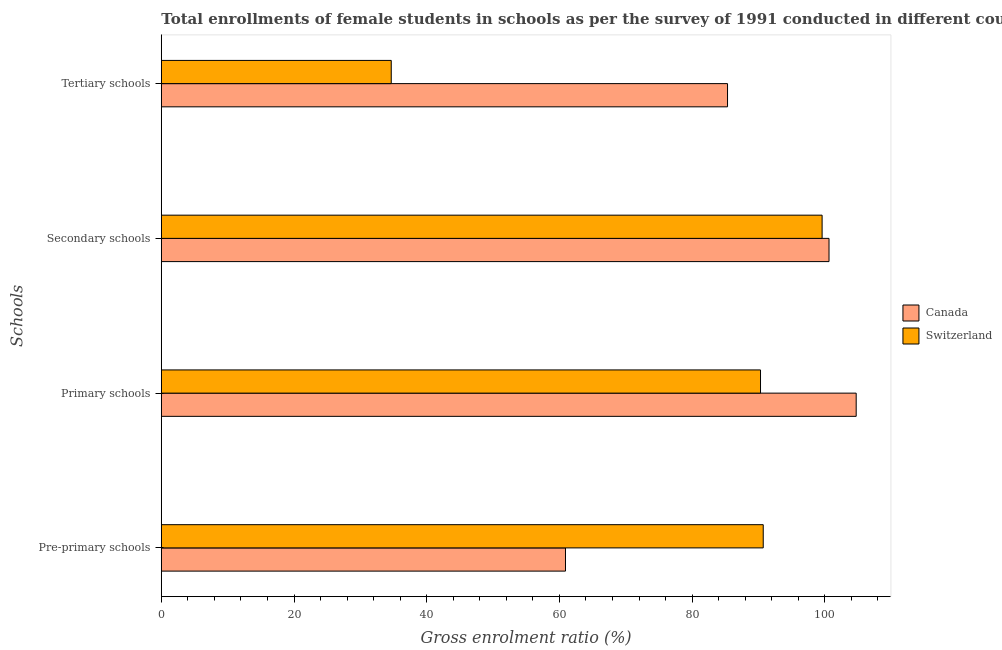How many groups of bars are there?
Offer a very short reply. 4. Are the number of bars per tick equal to the number of legend labels?
Provide a short and direct response. Yes. How many bars are there on the 1st tick from the top?
Give a very brief answer. 2. What is the label of the 4th group of bars from the top?
Keep it short and to the point. Pre-primary schools. What is the gross enrolment ratio(female) in secondary schools in Canada?
Offer a terse response. 100.64. Across all countries, what is the maximum gross enrolment ratio(female) in tertiary schools?
Provide a succinct answer. 85.34. Across all countries, what is the minimum gross enrolment ratio(female) in pre-primary schools?
Make the answer very short. 60.92. In which country was the gross enrolment ratio(female) in secondary schools minimum?
Give a very brief answer. Switzerland. What is the total gross enrolment ratio(female) in primary schools in the graph?
Provide a short and direct response. 195.05. What is the difference between the gross enrolment ratio(female) in secondary schools in Switzerland and that in Canada?
Make the answer very short. -1.04. What is the difference between the gross enrolment ratio(female) in secondary schools in Switzerland and the gross enrolment ratio(female) in primary schools in Canada?
Provide a succinct answer. -5.14. What is the average gross enrolment ratio(female) in pre-primary schools per country?
Offer a very short reply. 75.82. What is the difference between the gross enrolment ratio(female) in pre-primary schools and gross enrolment ratio(female) in secondary schools in Switzerland?
Offer a very short reply. -8.87. In how many countries, is the gross enrolment ratio(female) in primary schools greater than 92 %?
Ensure brevity in your answer.  1. What is the ratio of the gross enrolment ratio(female) in pre-primary schools in Canada to that in Switzerland?
Provide a short and direct response. 0.67. Is the gross enrolment ratio(female) in secondary schools in Switzerland less than that in Canada?
Provide a succinct answer. Yes. Is the difference between the gross enrolment ratio(female) in tertiary schools in Switzerland and Canada greater than the difference between the gross enrolment ratio(female) in secondary schools in Switzerland and Canada?
Your response must be concise. No. What is the difference between the highest and the second highest gross enrolment ratio(female) in tertiary schools?
Make the answer very short. 50.69. What is the difference between the highest and the lowest gross enrolment ratio(female) in pre-primary schools?
Your answer should be very brief. 29.81. In how many countries, is the gross enrolment ratio(female) in secondary schools greater than the average gross enrolment ratio(female) in secondary schools taken over all countries?
Keep it short and to the point. 1. Is it the case that in every country, the sum of the gross enrolment ratio(female) in secondary schools and gross enrolment ratio(female) in pre-primary schools is greater than the sum of gross enrolment ratio(female) in tertiary schools and gross enrolment ratio(female) in primary schools?
Provide a succinct answer. No. What does the 1st bar from the top in Secondary schools represents?
Offer a very short reply. Switzerland. What does the 1st bar from the bottom in Secondary schools represents?
Give a very brief answer. Canada. Is it the case that in every country, the sum of the gross enrolment ratio(female) in pre-primary schools and gross enrolment ratio(female) in primary schools is greater than the gross enrolment ratio(female) in secondary schools?
Provide a succinct answer. Yes. Are all the bars in the graph horizontal?
Keep it short and to the point. Yes. How many countries are there in the graph?
Offer a terse response. 2. Does the graph contain grids?
Your answer should be very brief. No. Where does the legend appear in the graph?
Keep it short and to the point. Center right. How many legend labels are there?
Provide a short and direct response. 2. How are the legend labels stacked?
Ensure brevity in your answer.  Vertical. What is the title of the graph?
Offer a very short reply. Total enrollments of female students in schools as per the survey of 1991 conducted in different countries. What is the label or title of the Y-axis?
Ensure brevity in your answer.  Schools. What is the Gross enrolment ratio (%) of Canada in Pre-primary schools?
Your answer should be very brief. 60.92. What is the Gross enrolment ratio (%) of Switzerland in Pre-primary schools?
Your answer should be compact. 90.73. What is the Gross enrolment ratio (%) of Canada in Primary schools?
Provide a succinct answer. 104.74. What is the Gross enrolment ratio (%) in Switzerland in Primary schools?
Offer a very short reply. 90.32. What is the Gross enrolment ratio (%) in Canada in Secondary schools?
Give a very brief answer. 100.64. What is the Gross enrolment ratio (%) in Switzerland in Secondary schools?
Offer a very short reply. 99.6. What is the Gross enrolment ratio (%) of Canada in Tertiary schools?
Offer a very short reply. 85.34. What is the Gross enrolment ratio (%) in Switzerland in Tertiary schools?
Offer a very short reply. 34.66. Across all Schools, what is the maximum Gross enrolment ratio (%) in Canada?
Offer a very short reply. 104.74. Across all Schools, what is the maximum Gross enrolment ratio (%) in Switzerland?
Offer a terse response. 99.6. Across all Schools, what is the minimum Gross enrolment ratio (%) in Canada?
Offer a terse response. 60.92. Across all Schools, what is the minimum Gross enrolment ratio (%) of Switzerland?
Give a very brief answer. 34.66. What is the total Gross enrolment ratio (%) of Canada in the graph?
Your answer should be very brief. 351.65. What is the total Gross enrolment ratio (%) of Switzerland in the graph?
Your answer should be very brief. 315.3. What is the difference between the Gross enrolment ratio (%) in Canada in Pre-primary schools and that in Primary schools?
Your answer should be very brief. -43.82. What is the difference between the Gross enrolment ratio (%) in Switzerland in Pre-primary schools and that in Primary schools?
Your answer should be compact. 0.41. What is the difference between the Gross enrolment ratio (%) in Canada in Pre-primary schools and that in Secondary schools?
Your response must be concise. -39.72. What is the difference between the Gross enrolment ratio (%) of Switzerland in Pre-primary schools and that in Secondary schools?
Provide a succinct answer. -8.87. What is the difference between the Gross enrolment ratio (%) of Canada in Pre-primary schools and that in Tertiary schools?
Your answer should be compact. -24.42. What is the difference between the Gross enrolment ratio (%) in Switzerland in Pre-primary schools and that in Tertiary schools?
Offer a terse response. 56.07. What is the difference between the Gross enrolment ratio (%) in Canada in Primary schools and that in Secondary schools?
Provide a short and direct response. 4.09. What is the difference between the Gross enrolment ratio (%) in Switzerland in Primary schools and that in Secondary schools?
Provide a succinct answer. -9.29. What is the difference between the Gross enrolment ratio (%) of Canada in Primary schools and that in Tertiary schools?
Offer a very short reply. 19.39. What is the difference between the Gross enrolment ratio (%) in Switzerland in Primary schools and that in Tertiary schools?
Ensure brevity in your answer.  55.66. What is the difference between the Gross enrolment ratio (%) of Canada in Secondary schools and that in Tertiary schools?
Offer a terse response. 15.3. What is the difference between the Gross enrolment ratio (%) in Switzerland in Secondary schools and that in Tertiary schools?
Ensure brevity in your answer.  64.94. What is the difference between the Gross enrolment ratio (%) in Canada in Pre-primary schools and the Gross enrolment ratio (%) in Switzerland in Primary schools?
Give a very brief answer. -29.4. What is the difference between the Gross enrolment ratio (%) of Canada in Pre-primary schools and the Gross enrolment ratio (%) of Switzerland in Secondary schools?
Offer a terse response. -38.68. What is the difference between the Gross enrolment ratio (%) in Canada in Pre-primary schools and the Gross enrolment ratio (%) in Switzerland in Tertiary schools?
Give a very brief answer. 26.26. What is the difference between the Gross enrolment ratio (%) of Canada in Primary schools and the Gross enrolment ratio (%) of Switzerland in Secondary schools?
Ensure brevity in your answer.  5.14. What is the difference between the Gross enrolment ratio (%) in Canada in Primary schools and the Gross enrolment ratio (%) in Switzerland in Tertiary schools?
Offer a very short reply. 70.08. What is the difference between the Gross enrolment ratio (%) in Canada in Secondary schools and the Gross enrolment ratio (%) in Switzerland in Tertiary schools?
Your response must be concise. 65.98. What is the average Gross enrolment ratio (%) of Canada per Schools?
Ensure brevity in your answer.  87.91. What is the average Gross enrolment ratio (%) in Switzerland per Schools?
Give a very brief answer. 78.83. What is the difference between the Gross enrolment ratio (%) of Canada and Gross enrolment ratio (%) of Switzerland in Pre-primary schools?
Ensure brevity in your answer.  -29.81. What is the difference between the Gross enrolment ratio (%) of Canada and Gross enrolment ratio (%) of Switzerland in Primary schools?
Ensure brevity in your answer.  14.42. What is the difference between the Gross enrolment ratio (%) of Canada and Gross enrolment ratio (%) of Switzerland in Secondary schools?
Ensure brevity in your answer.  1.04. What is the difference between the Gross enrolment ratio (%) of Canada and Gross enrolment ratio (%) of Switzerland in Tertiary schools?
Your answer should be compact. 50.69. What is the ratio of the Gross enrolment ratio (%) in Canada in Pre-primary schools to that in Primary schools?
Offer a terse response. 0.58. What is the ratio of the Gross enrolment ratio (%) of Canada in Pre-primary schools to that in Secondary schools?
Offer a terse response. 0.61. What is the ratio of the Gross enrolment ratio (%) in Switzerland in Pre-primary schools to that in Secondary schools?
Offer a very short reply. 0.91. What is the ratio of the Gross enrolment ratio (%) of Canada in Pre-primary schools to that in Tertiary schools?
Your response must be concise. 0.71. What is the ratio of the Gross enrolment ratio (%) of Switzerland in Pre-primary schools to that in Tertiary schools?
Make the answer very short. 2.62. What is the ratio of the Gross enrolment ratio (%) in Canada in Primary schools to that in Secondary schools?
Ensure brevity in your answer.  1.04. What is the ratio of the Gross enrolment ratio (%) in Switzerland in Primary schools to that in Secondary schools?
Provide a short and direct response. 0.91. What is the ratio of the Gross enrolment ratio (%) in Canada in Primary schools to that in Tertiary schools?
Offer a terse response. 1.23. What is the ratio of the Gross enrolment ratio (%) of Switzerland in Primary schools to that in Tertiary schools?
Your answer should be very brief. 2.61. What is the ratio of the Gross enrolment ratio (%) of Canada in Secondary schools to that in Tertiary schools?
Keep it short and to the point. 1.18. What is the ratio of the Gross enrolment ratio (%) of Switzerland in Secondary schools to that in Tertiary schools?
Your response must be concise. 2.87. What is the difference between the highest and the second highest Gross enrolment ratio (%) in Canada?
Give a very brief answer. 4.09. What is the difference between the highest and the second highest Gross enrolment ratio (%) of Switzerland?
Offer a very short reply. 8.87. What is the difference between the highest and the lowest Gross enrolment ratio (%) in Canada?
Keep it short and to the point. 43.82. What is the difference between the highest and the lowest Gross enrolment ratio (%) of Switzerland?
Your response must be concise. 64.94. 